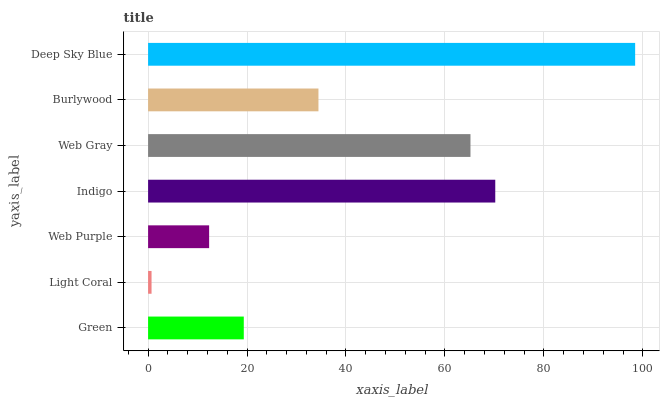Is Light Coral the minimum?
Answer yes or no. Yes. Is Deep Sky Blue the maximum?
Answer yes or no. Yes. Is Web Purple the minimum?
Answer yes or no. No. Is Web Purple the maximum?
Answer yes or no. No. Is Web Purple greater than Light Coral?
Answer yes or no. Yes. Is Light Coral less than Web Purple?
Answer yes or no. Yes. Is Light Coral greater than Web Purple?
Answer yes or no. No. Is Web Purple less than Light Coral?
Answer yes or no. No. Is Burlywood the high median?
Answer yes or no. Yes. Is Burlywood the low median?
Answer yes or no. Yes. Is Web Gray the high median?
Answer yes or no. No. Is Web Gray the low median?
Answer yes or no. No. 